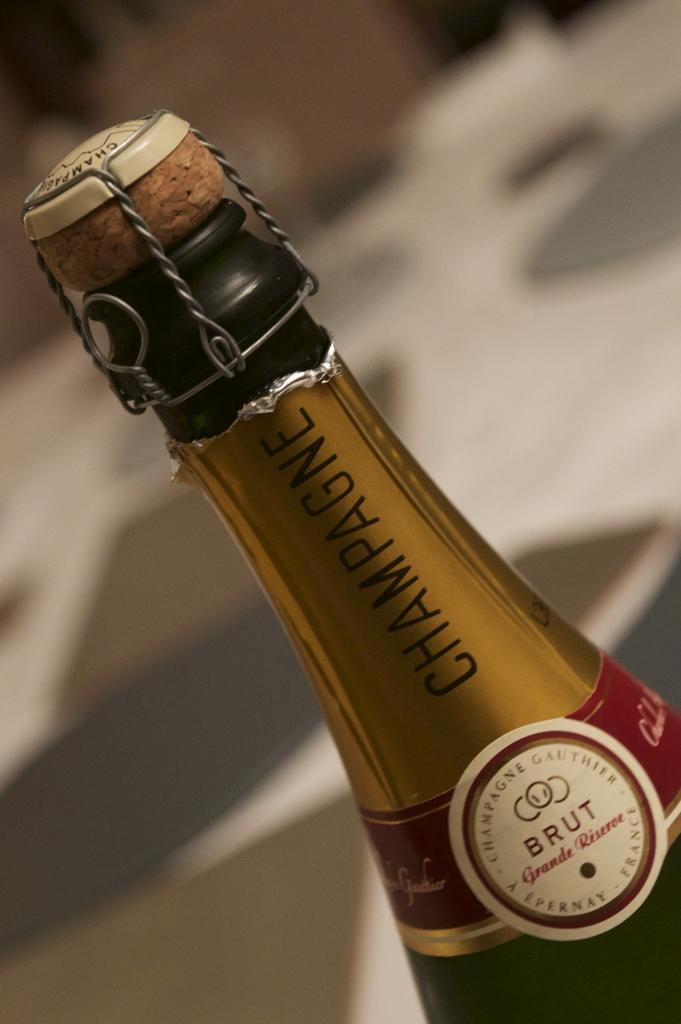What is the main subject of the image? The main subject of the image is a wine bottle. Where is the wine bottle located in the image? The wine bottle is in the middle of the image. How many babies can be seen playing in the alley in the image? There are no babies or alleys present in the image; it features a wine bottle in the middle. 